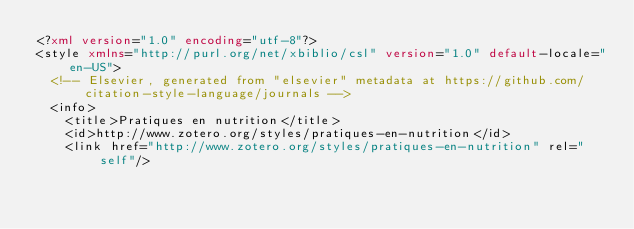Convert code to text. <code><loc_0><loc_0><loc_500><loc_500><_XML_><?xml version="1.0" encoding="utf-8"?>
<style xmlns="http://purl.org/net/xbiblio/csl" version="1.0" default-locale="en-US">
  <!-- Elsevier, generated from "elsevier" metadata at https://github.com/citation-style-language/journals -->
  <info>
    <title>Pratiques en nutrition</title>
    <id>http://www.zotero.org/styles/pratiques-en-nutrition</id>
    <link href="http://www.zotero.org/styles/pratiques-en-nutrition" rel="self"/></code> 